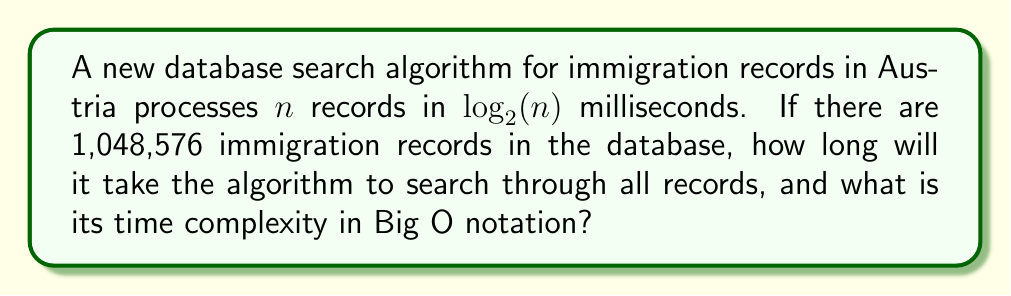Help me with this question. To solve this problem, we need to follow these steps:

1. Identify the number of records:
   $n = 1,048,576$

2. Calculate the time taken:
   The algorithm processes $n$ records in $\log_2(n)$ milliseconds.
   Time = $\log_2(1,048,576)$ ms
   
   To calculate this:
   $2^{20} = 1,048,576$
   Therefore, $\log_2(1,048,576) = 20$ ms

3. Determine the time complexity:
   The time complexity is $O(\log n)$ because the time taken is logarithmic in relation to the input size.

This algorithm is highly efficient for large datasets, as it uses a logarithmic time complexity, which is characteristic of binary search or balanced tree data structures. For an immigration lawyer in Austria, this means that even with a large number of records, searches can be performed very quickly, allowing for efficient processing of cases and queries.
Answer: The algorithm will take 20 milliseconds to search through all 1,048,576 records. The time complexity is $O(\log n)$. 